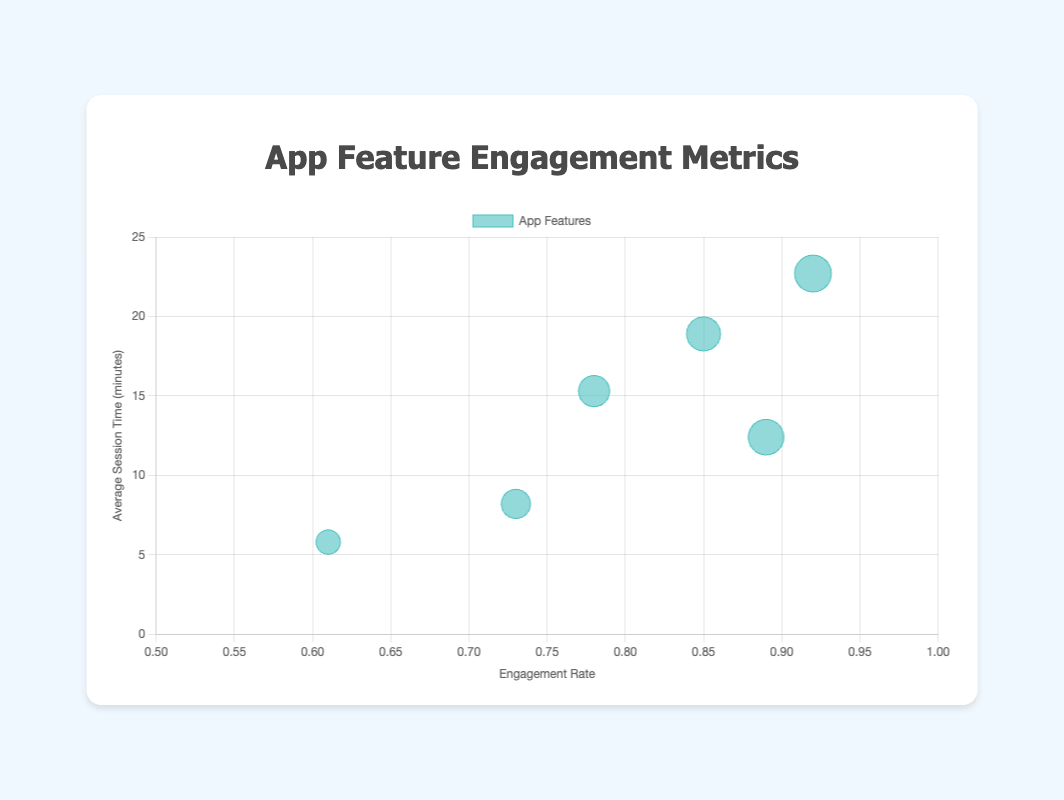Which feature has the highest engagement rate? The social feed (📱) has the highest engagement rate of 0.92. This can be easily observed as it's the feature placed farthest to the right on the x-axis (Engagement Rate).
Answer: Social Feed Which feature has the lowest average session time? The virtual gifts (🎁) have the lowest average session time of 5.8 minutes, as it's the feature positioned lowest on the y-axis (Average Session Time).
Answer: Virtual Gifts How does the average session time for the social feed compare to that of live streaming? The average session time for the social feed (📱) is 22.7 minutes, while for live streaming (📹), it is 15.3 minutes. Comparing these values, the social feed's session time is higher by 22.7 - 15.3 = 7.4 minutes.
Answer: 7.4 minutes Which feature (with emojis) has an engagement rate greater than 0.8 but less than 0.9? Features with engagement rates between 0.8 and 0.9 include live streaming (📹) at 0.78, in-app challenges (🏆) at 0.85, and messaging (💬) at 0.89. Filtering out those not fitting this range, in-app challenges and messaging meet the criteria.
Answer: 🏆, 💬 Which feature has a higher engagement rate: user profiles or live streaming? Live streaming (📹) has an engagement rate of 0.78, while user profiles (👤) have an engagement rate of 0.73. Thus, live streaming has a higher engagement rate by 0.05.
Answer: Live Streaming What is the total average session time for in-app challenges and messaging? The average session time for in-app challenges (🏆) is 18.9 minutes, and for messaging (💬), it is 12.4 minutes. Adding these together gives 18.9 + 12.4 = 31.3 minutes.
Answer: 31.3 minutes Which feature has the smallest bubble size and what does that represent? The virtual gifts (🎁) feature has the smallest bubble size, representing its relatively low engagement rate of 0.61. Bubble sizes are determined by engagement rates scaled for visibility on the chart.
Answer: Virtual Gifts What is the bubble size for a feature with an engagement rate of 0.85? The only bubble with an engagement rate of 0.85 is for in-app challenges (🏆). Bubble sizes are engagement rates scaled by 20, so 0.85 * 20 = 17.
Answer: 17 How does the engagement rate of social feed compare to the engagement rate of virtual gifts and user profiles combined? The engagement rate for the social feed (📱) is 0.92. The combined engagement rate for virtual gifts (🎁) and user profiles (👤) is 0.61 + 0.73 = 1.34. When compared, 0.92 is less than 1.34.
Answer: Less Which features have both an engagement rate and average session time above their respective medians? To identify these features, we need to calculate the median engagement rate and median average session time. Median engagement rate: 0.78, 0.73, 0.92, 0.85, 0.89, 0.61 sorted is 0.73, 0.78, 0.85, 0.89, median is (0.85+0.78)/2 = 0.815. Median average session time: 15.3, 22.7, 18.9, 12.4, 5.8, 8.2 sorted is 8.2, 12.4, 15.3, 18.9, 22.7, median is (15.3+18.9)/2 = 17.1. Features above median in both: in-app challenges (0.85, 18.9), social feed (0.92, 22.7), and messaging (0.89, 12.4).
Answer: In-app challenges 🏆, Social feed 📱, Messaging 💬 